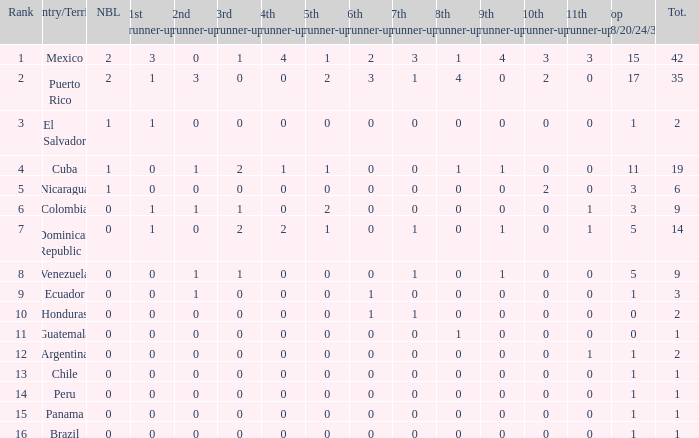What is the 7th runner-up of the country with a 10th runner-up greater than 0, a 9th runner-up greater than 0, and an 8th runner-up greater than 1? None. 